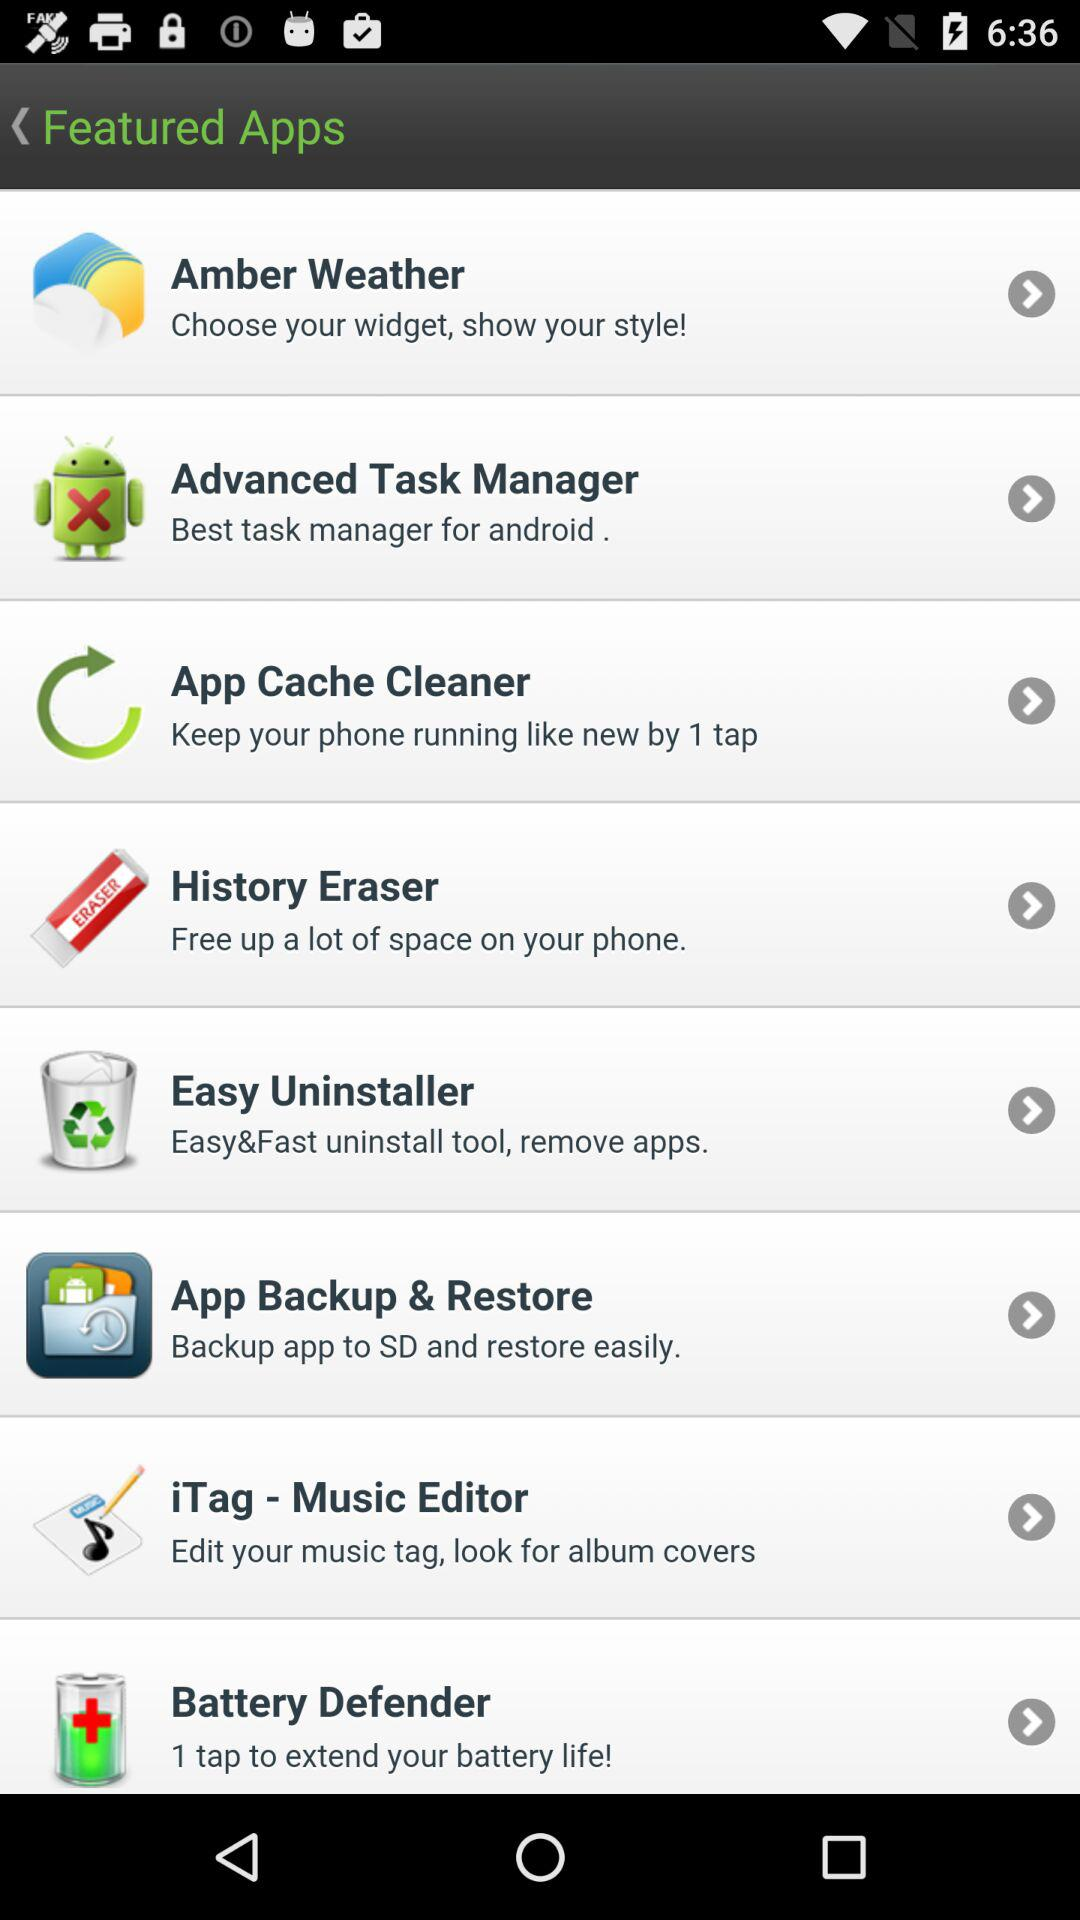What application can we use to free up a lot of space? The application is "History Eraser". 